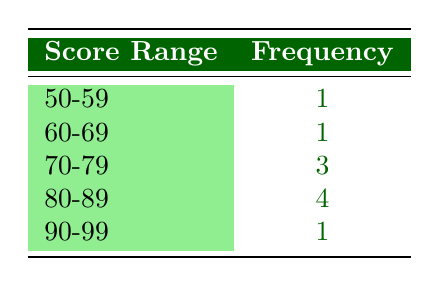What is the frequency of rallies with a score between 70 and 79? The table shows the score range of 70-79 and its corresponding frequency, which is listed as 3.
Answer: 3 How many rallies received a score of 80 or above? To find out the number of rallies with a score of 80 or above, look at the frequencies for the score ranges 80-89 and 90-99. Adding these frequencies gives 4 (for 80-89) + 1 (for 90-99) = 5.
Answer: 5 Is there any rally that scored 55 or below? The table indicates that the lowest score range is 50-59 and has a frequency of 1, which means there was one rally that scored in that range. Therefore, yes, there was a rally that scored 55 or below.
Answer: Yes What is the average score of rallies that scored in the 80-89 range? The total score for the score range 80-89 consists of the following: 85 (Green Earth Rally 2021), 82 (Planet Protectors Rally 2021), 88 (Earth Day Run 2022), and 80 (Clean Ocean Rally 2021). The sum is (85 + 82 + 88 + 80) = 335. There are 4 rallies in this range, so the average is 335 / 4 = 83.75.
Answer: 83.75 How many score ranges have a frequency of 1? The score ranges with a frequency of 1 are 50-59 (1) and 90-99 (1). Counting these, there are 2 score ranges that have a frequency of 1.
Answer: 2 